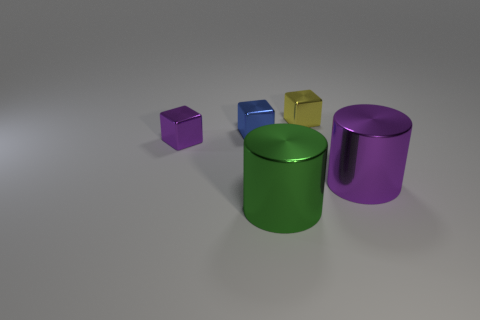What material is the object that is behind the small purple thing and right of the blue object?
Your response must be concise. Metal. How many matte objects are big red cubes or cubes?
Make the answer very short. 0. What is the shape of the small purple object that is the same material as the green thing?
Your response must be concise. Cube. What number of things are behind the large green cylinder and in front of the tiny purple object?
Your response must be concise. 1. Are there any other things that are the same shape as the big purple metal thing?
Your response must be concise. Yes. There is a purple thing that is to the right of the big green thing; how big is it?
Your response must be concise. Large. What number of small blue objects are the same shape as the small yellow metallic thing?
Keep it short and to the point. 1. What size is the green cylinder that is made of the same material as the yellow cube?
Offer a terse response. Large. Is there a metallic cylinder left of the small metal cube that is behind the tiny blue metal object that is in front of the yellow metal cube?
Your response must be concise. Yes. Is the size of the metal object on the right side of the yellow metal block the same as the purple block?
Make the answer very short. No. 